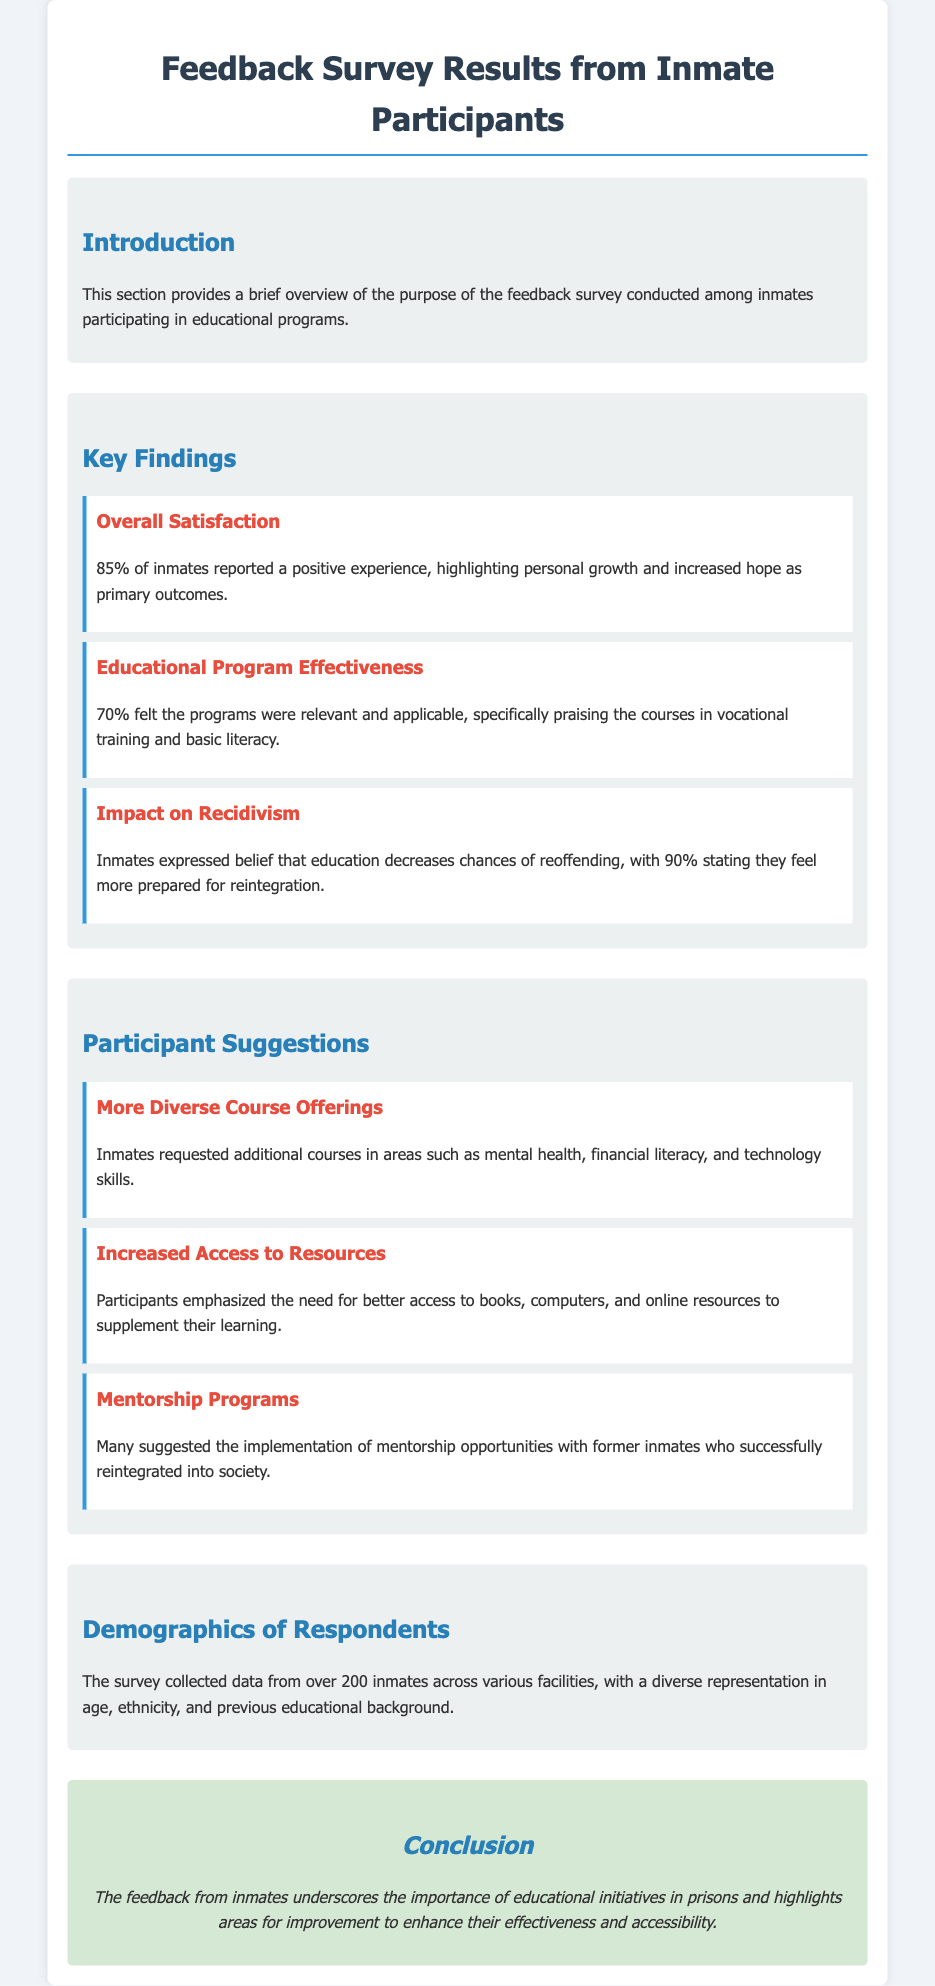What percentage of inmates reported a positive experience? The document states that 85% of inmates reported a positive experience from the survey results.
Answer: 85% What do 90% of inmates believe regarding education and reoffending? According to the survey, 90% of inmates stated they feel more prepared for reintegration, implying a belief that education decreases chances of reoffending.
Answer: Decreases chances of reoffending What specific outcomes did inmates highlight as primary? The primary outcomes highlighted by inmates include personal growth and increased hope as stated in the key findings.
Answer: Personal growth and increased hope What type of additional courses did inmates request? Inmates requested more diverse course offerings, including mental health, financial literacy, and technology skills, as noted in their suggestions.
Answer: Mental health, financial literacy, and technology skills How many inmates participated in the survey? The document indicates that over 200 inmates participated in the survey across various facilities.
Answer: Over 200 inmates What was the effectiveness rating of the educational programs? The survey results show that 70% felt the programs were relevant and applicable, demonstrating a positive effectiveness rating.
Answer: 70% What is the purpose of the feedback survey? The introduction section mentions that the purpose is to gather insights into the experiences of inmates participating in educational programs.
Answer: Gather insights into experiences What is one method suggested for enhancing support for inmates? One suggestion made by participants was the implementation of mentorship programs with former inmates who successfully reintegrated into society.
Answer: Mentorship programs What aspect of resources did participants want increased access to? Participants emphasized the need for better access to books, computers, and online resources to supplement their learning.
Answer: Books, computers, and online resources 